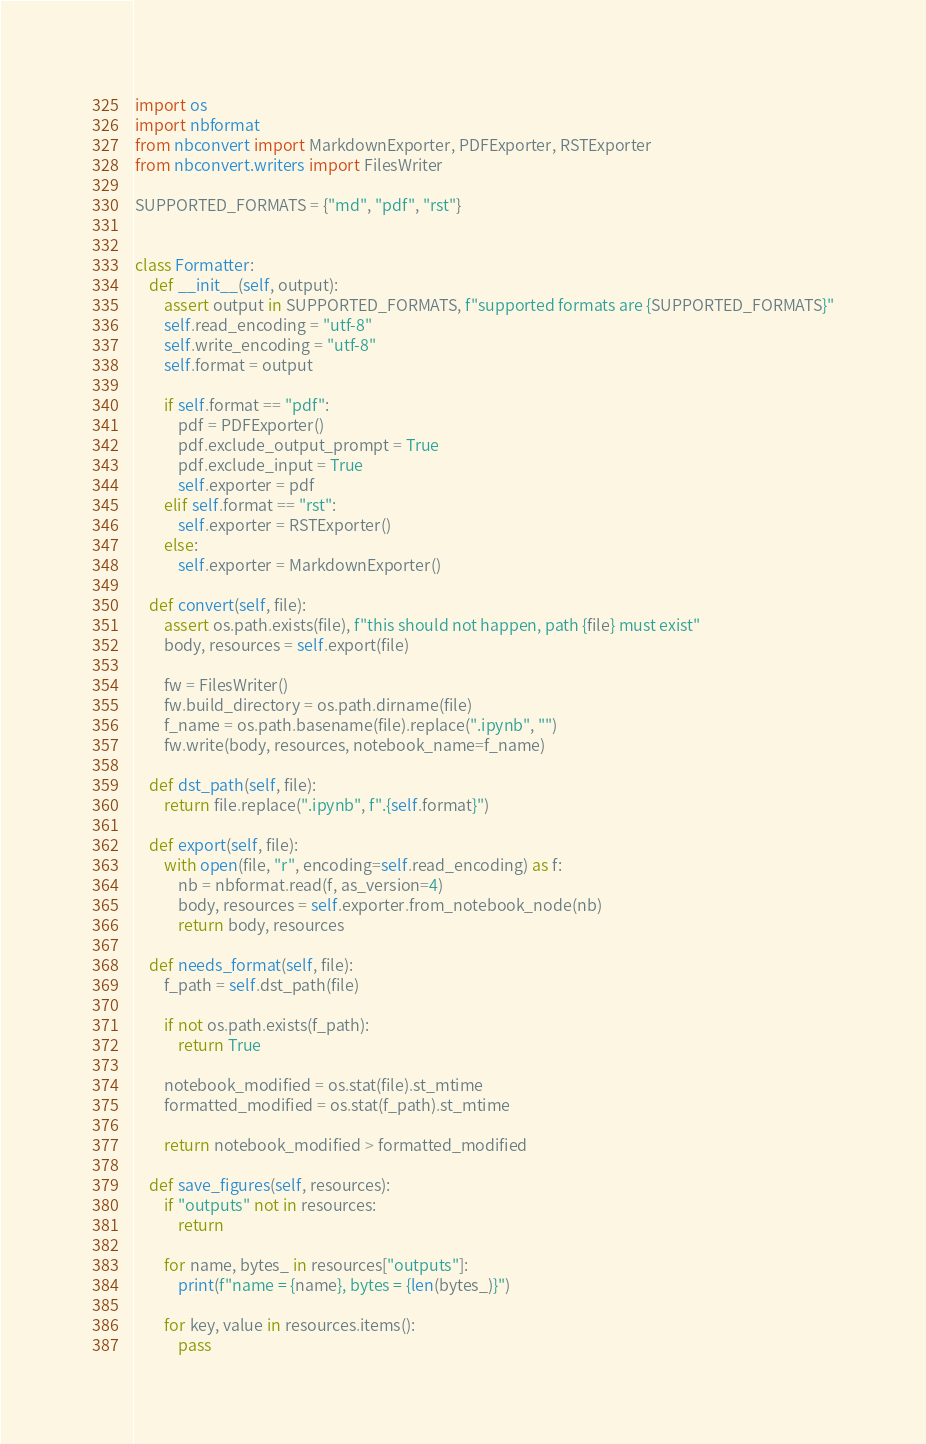Convert code to text. <code><loc_0><loc_0><loc_500><loc_500><_Python_>import os
import nbformat
from nbconvert import MarkdownExporter, PDFExporter, RSTExporter
from nbconvert.writers import FilesWriter

SUPPORTED_FORMATS = {"md", "pdf", "rst"}


class Formatter:
    def __init__(self, output):
        assert output in SUPPORTED_FORMATS, f"supported formats are {SUPPORTED_FORMATS}"
        self.read_encoding = "utf-8"
        self.write_encoding = "utf-8"
        self.format = output

        if self.format == "pdf":
            pdf = PDFExporter()
            pdf.exclude_output_prompt = True
            pdf.exclude_input = True
            self.exporter = pdf
        elif self.format == "rst":
            self.exporter = RSTExporter()
        else:
            self.exporter = MarkdownExporter()

    def convert(self, file):
        assert os.path.exists(file), f"this should not happen, path {file} must exist"
        body, resources = self.export(file)

        fw = FilesWriter()
        fw.build_directory = os.path.dirname(file)
        f_name = os.path.basename(file).replace(".ipynb", "")
        fw.write(body, resources, notebook_name=f_name)

    def dst_path(self, file):
        return file.replace(".ipynb", f".{self.format}")

    def export(self, file):
        with open(file, "r", encoding=self.read_encoding) as f:
            nb = nbformat.read(f, as_version=4)
            body, resources = self.exporter.from_notebook_node(nb)
            return body, resources

    def needs_format(self, file):
        f_path = self.dst_path(file)

        if not os.path.exists(f_path):
            return True

        notebook_modified = os.stat(file).st_mtime
        formatted_modified = os.stat(f_path).st_mtime

        return notebook_modified > formatted_modified

    def save_figures(self, resources):
        if "outputs" not in resources:
            return

        for name, bytes_ in resources["outputs"]:
            print(f"name = {name}, bytes = {len(bytes_)}")

        for key, value in resources.items():
            pass
</code> 